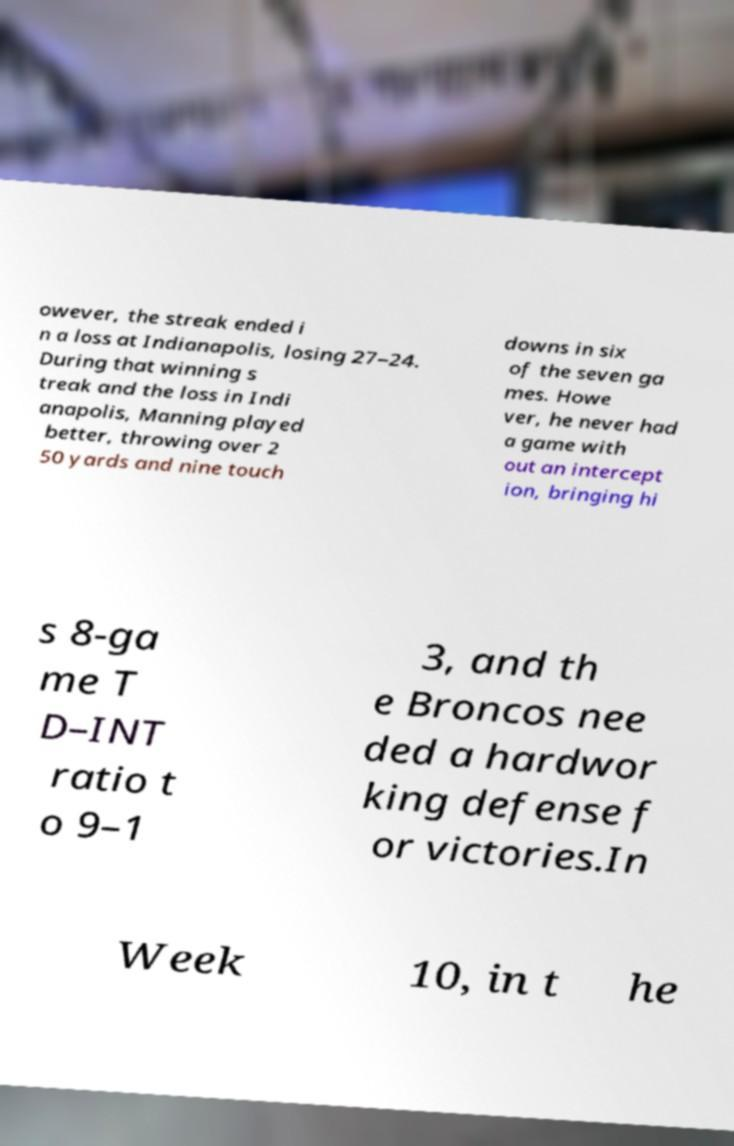Can you accurately transcribe the text from the provided image for me? owever, the streak ended i n a loss at Indianapolis, losing 27–24. During that winning s treak and the loss in Indi anapolis, Manning played better, throwing over 2 50 yards and nine touch downs in six of the seven ga mes. Howe ver, he never had a game with out an intercept ion, bringing hi s 8-ga me T D–INT ratio t o 9–1 3, and th e Broncos nee ded a hardwor king defense f or victories.In Week 10, in t he 